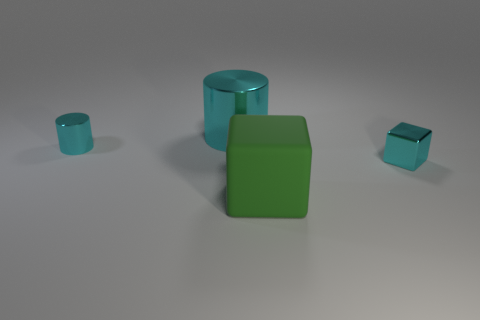Add 1 large brown cubes. How many objects exist? 5 Subtract 1 cyan blocks. How many objects are left? 3 Subtract all green rubber objects. Subtract all blue shiny cylinders. How many objects are left? 3 Add 4 large blocks. How many large blocks are left? 5 Add 1 large metallic cylinders. How many large metallic cylinders exist? 2 